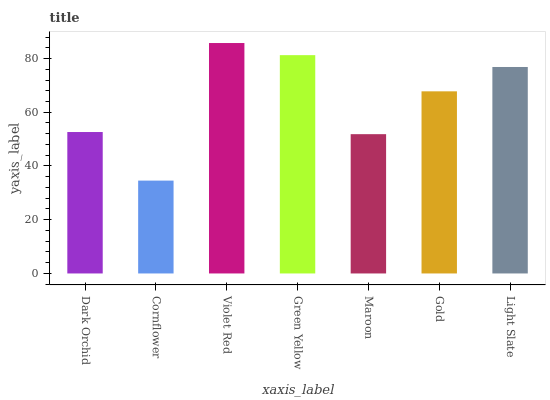Is Cornflower the minimum?
Answer yes or no. Yes. Is Violet Red the maximum?
Answer yes or no. Yes. Is Violet Red the minimum?
Answer yes or no. No. Is Cornflower the maximum?
Answer yes or no. No. Is Violet Red greater than Cornflower?
Answer yes or no. Yes. Is Cornflower less than Violet Red?
Answer yes or no. Yes. Is Cornflower greater than Violet Red?
Answer yes or no. No. Is Violet Red less than Cornflower?
Answer yes or no. No. Is Gold the high median?
Answer yes or no. Yes. Is Gold the low median?
Answer yes or no. Yes. Is Dark Orchid the high median?
Answer yes or no. No. Is Dark Orchid the low median?
Answer yes or no. No. 